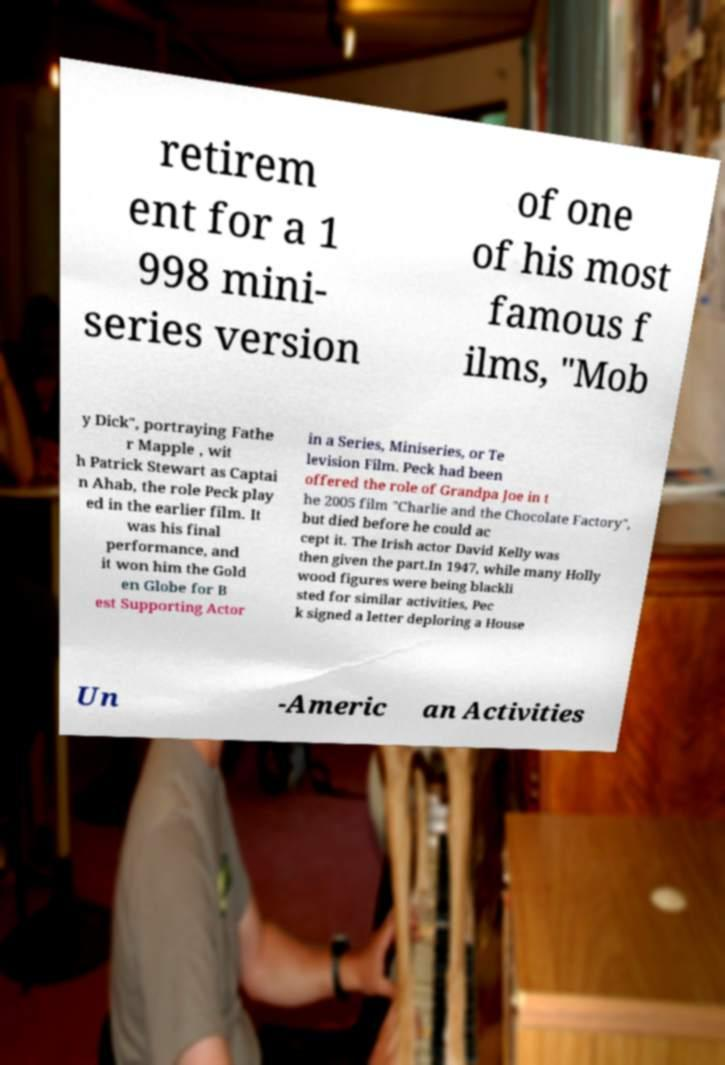For documentation purposes, I need the text within this image transcribed. Could you provide that? retirem ent for a 1 998 mini- series version of one of his most famous f ilms, "Mob y Dick", portraying Fathe r Mapple , wit h Patrick Stewart as Captai n Ahab, the role Peck play ed in the earlier film. It was his final performance, and it won him the Gold en Globe for B est Supporting Actor in a Series, Miniseries, or Te levision Film. Peck had been offered the role of Grandpa Joe in t he 2005 film "Charlie and the Chocolate Factory", but died before he could ac cept it. The Irish actor David Kelly was then given the part.In 1947, while many Holly wood figures were being blackli sted for similar activities, Pec k signed a letter deploring a House Un -Americ an Activities 